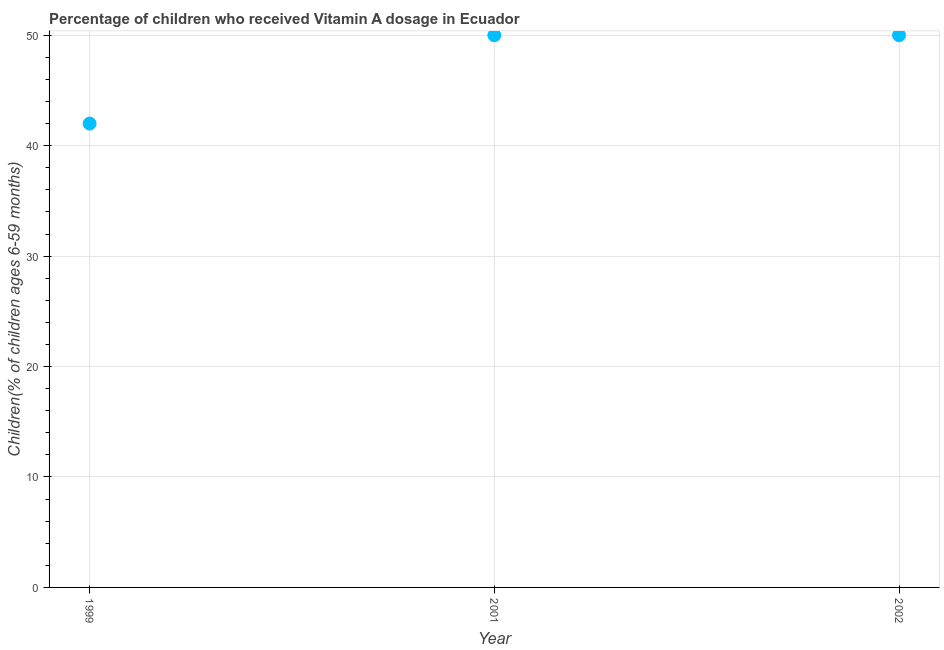What is the vitamin a supplementation coverage rate in 1999?
Offer a very short reply. 42. Across all years, what is the maximum vitamin a supplementation coverage rate?
Your answer should be very brief. 50. Across all years, what is the minimum vitamin a supplementation coverage rate?
Offer a very short reply. 42. What is the sum of the vitamin a supplementation coverage rate?
Your answer should be very brief. 142. What is the difference between the vitamin a supplementation coverage rate in 2001 and 2002?
Ensure brevity in your answer.  0. What is the average vitamin a supplementation coverage rate per year?
Make the answer very short. 47.33. In how many years, is the vitamin a supplementation coverage rate greater than 24 %?
Make the answer very short. 3. Do a majority of the years between 1999 and 2002 (inclusive) have vitamin a supplementation coverage rate greater than 40 %?
Offer a very short reply. Yes. What is the ratio of the vitamin a supplementation coverage rate in 1999 to that in 2002?
Ensure brevity in your answer.  0.84. Is the vitamin a supplementation coverage rate in 2001 less than that in 2002?
Offer a terse response. No. Is the difference between the vitamin a supplementation coverage rate in 1999 and 2002 greater than the difference between any two years?
Ensure brevity in your answer.  Yes. Is the sum of the vitamin a supplementation coverage rate in 1999 and 2002 greater than the maximum vitamin a supplementation coverage rate across all years?
Offer a very short reply. Yes. What is the difference between the highest and the lowest vitamin a supplementation coverage rate?
Provide a succinct answer. 8. What is the difference between two consecutive major ticks on the Y-axis?
Give a very brief answer. 10. Does the graph contain any zero values?
Your answer should be compact. No. What is the title of the graph?
Keep it short and to the point. Percentage of children who received Vitamin A dosage in Ecuador. What is the label or title of the X-axis?
Provide a succinct answer. Year. What is the label or title of the Y-axis?
Offer a very short reply. Children(% of children ages 6-59 months). What is the difference between the Children(% of children ages 6-59 months) in 1999 and 2001?
Your answer should be very brief. -8. What is the difference between the Children(% of children ages 6-59 months) in 1999 and 2002?
Offer a terse response. -8. What is the ratio of the Children(% of children ages 6-59 months) in 1999 to that in 2001?
Offer a very short reply. 0.84. What is the ratio of the Children(% of children ages 6-59 months) in 1999 to that in 2002?
Offer a very short reply. 0.84. What is the ratio of the Children(% of children ages 6-59 months) in 2001 to that in 2002?
Your answer should be very brief. 1. 